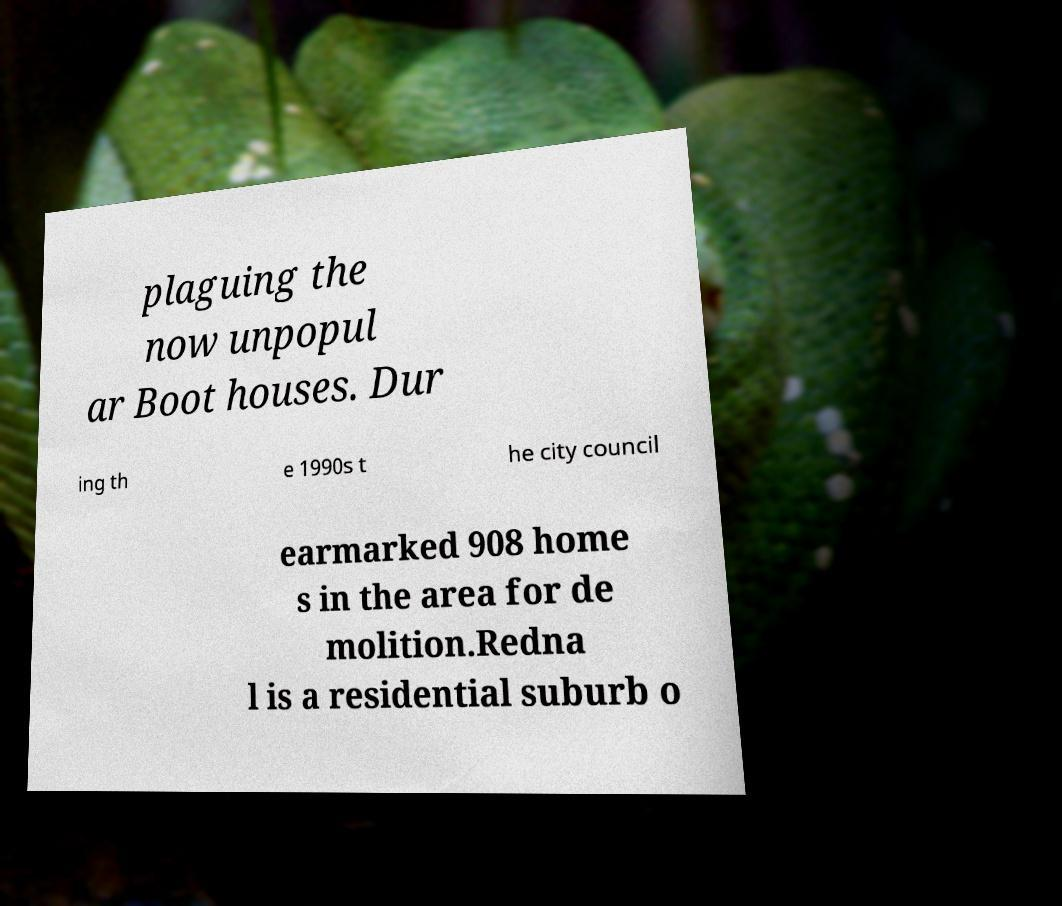Could you assist in decoding the text presented in this image and type it out clearly? plaguing the now unpopul ar Boot houses. Dur ing th e 1990s t he city council earmarked 908 home s in the area for de molition.Redna l is a residential suburb o 